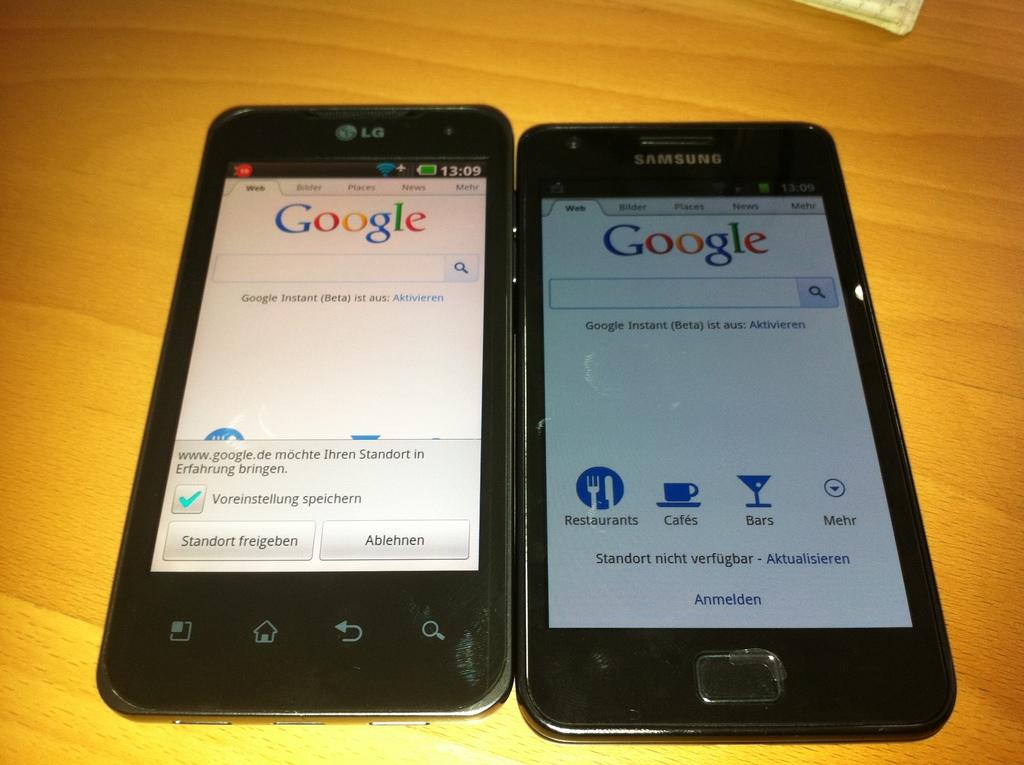What brand of phone is this?
Your response must be concise. Samsung. What website are both phones on?
Offer a terse response. Google. 